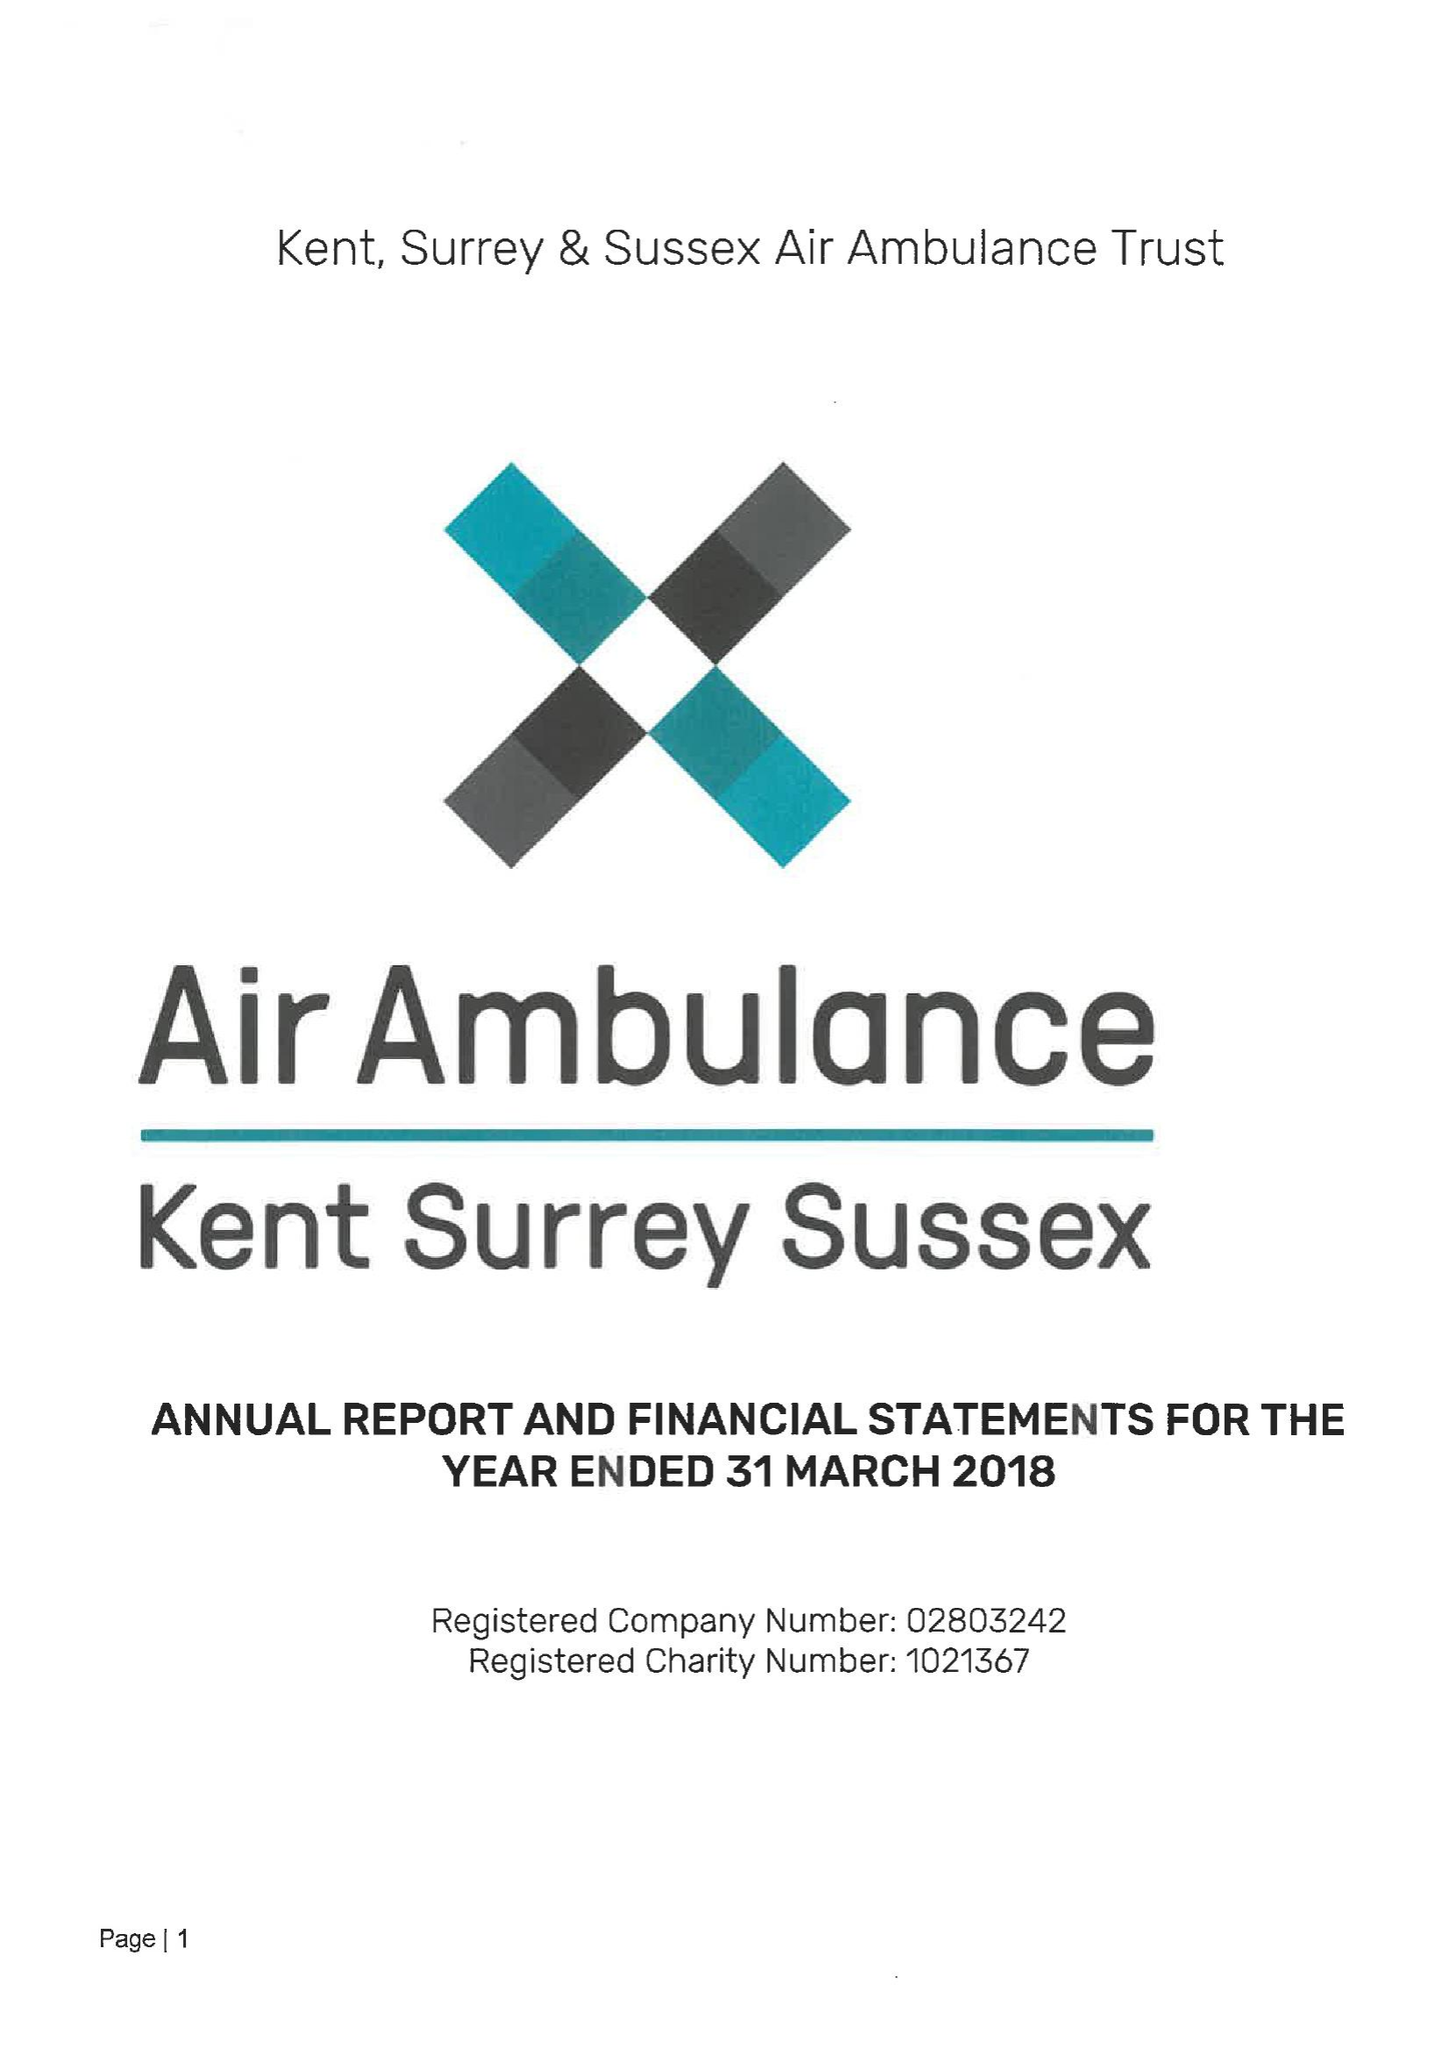What is the value for the charity_name?
Answer the question using a single word or phrase. Kent, Surrey and Sussex Air Ambulance Trust 